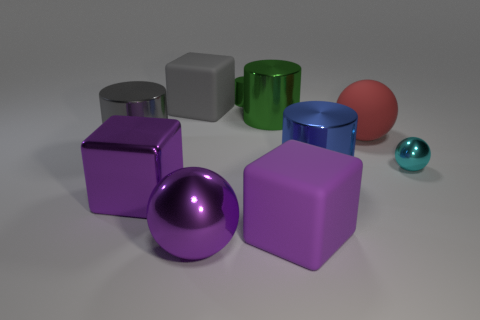What number of cylinders are behind the purple metal cube?
Offer a terse response. 4. Are there any gray matte blocks that have the same size as the metallic cube?
Your answer should be compact. Yes. Does the metal block have the same color as the large metallic ball?
Offer a very short reply. Yes. The large metallic cylinder that is on the left side of the cube behind the red rubber ball is what color?
Your response must be concise. Gray. How many cylinders are in front of the cyan metallic sphere and behind the large gray block?
Make the answer very short. 0. How many large green things are the same shape as the blue metal object?
Offer a very short reply. 1. Is the blue object made of the same material as the tiny cylinder?
Provide a short and direct response. Yes. What is the shape of the shiny object in front of the purple block on the left side of the purple metallic sphere?
Your answer should be compact. Sphere. How many purple blocks are right of the large sphere that is in front of the big blue metal thing?
Your answer should be very brief. 1. There is a object that is right of the blue object and behind the small cyan sphere; what material is it?
Your answer should be compact. Rubber. 